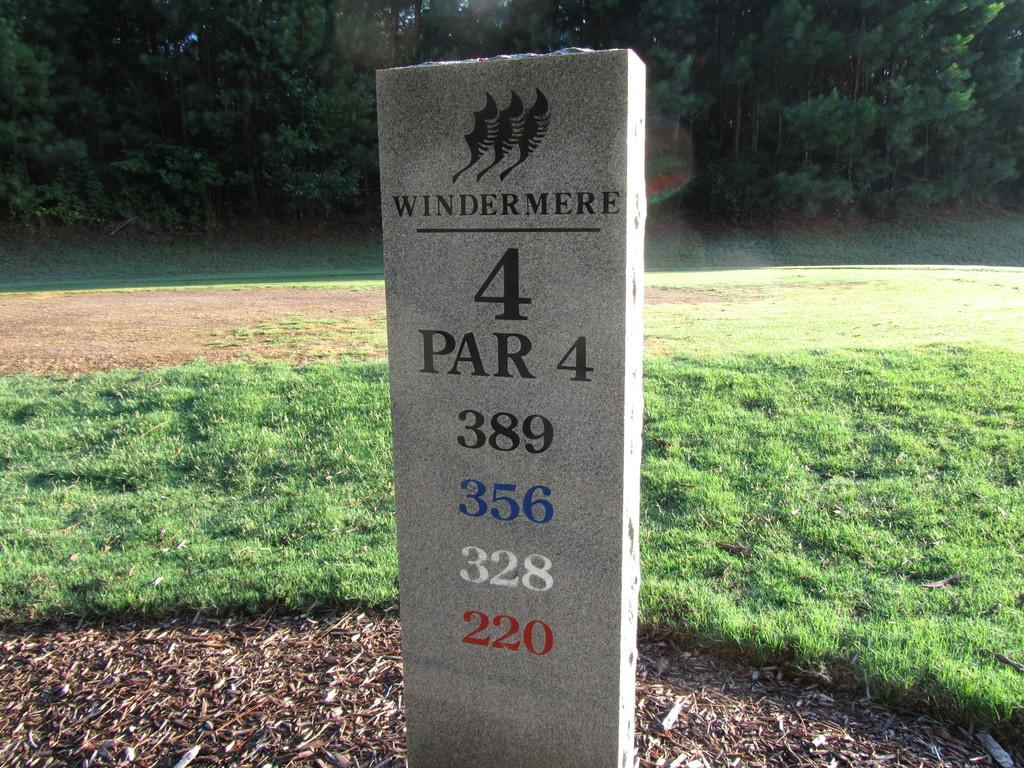What is the main object in the image? There is a milestone in the image. What information is displayed on the milestone? There are numbers written on the milestone. What type of vegetation is visible behind the milestone? There is grass visible behind the milestone. What can be seen in the distance in the image? There are trees in the background of the image. What type of metal is the beetle crawling on in the image? There is no beetle present in the image, and therefore no such activity can be observed. 